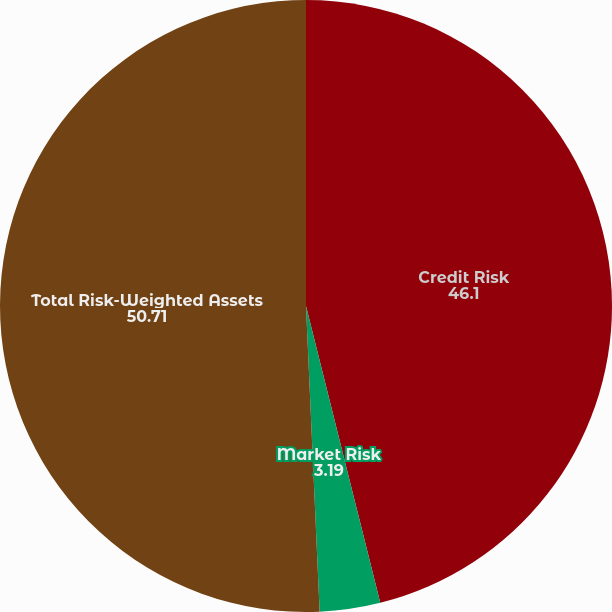<chart> <loc_0><loc_0><loc_500><loc_500><pie_chart><fcel>Credit Risk<fcel>Market Risk<fcel>Total Risk-Weighted Assets<nl><fcel>46.1%<fcel>3.19%<fcel>50.71%<nl></chart> 